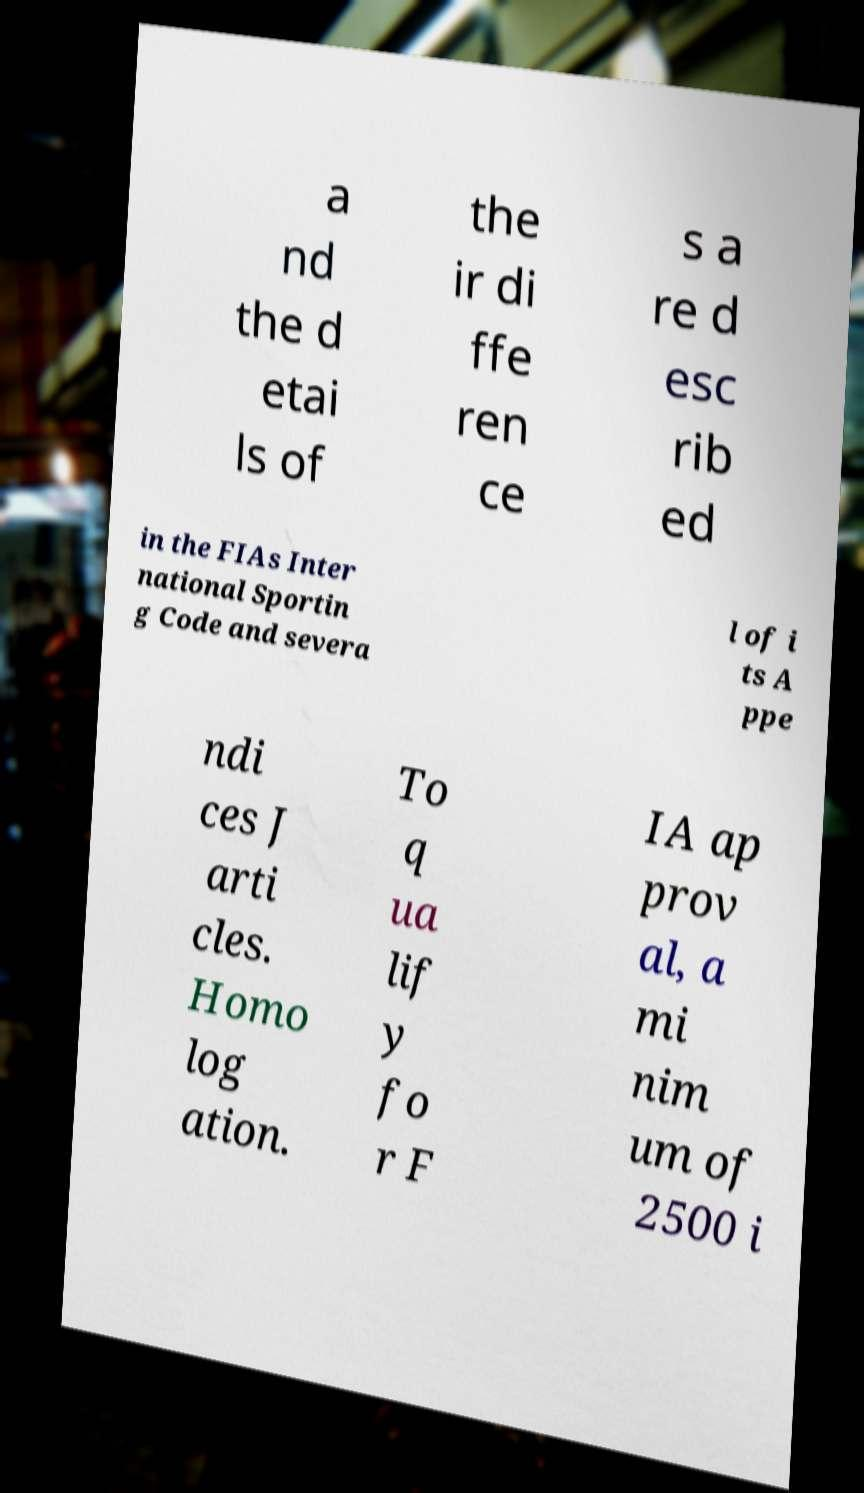There's text embedded in this image that I need extracted. Can you transcribe it verbatim? a nd the d etai ls of the ir di ffe ren ce s a re d esc rib ed in the FIAs Inter national Sportin g Code and severa l of i ts A ppe ndi ces J arti cles. Homo log ation. To q ua lif y fo r F IA ap prov al, a mi nim um of 2500 i 